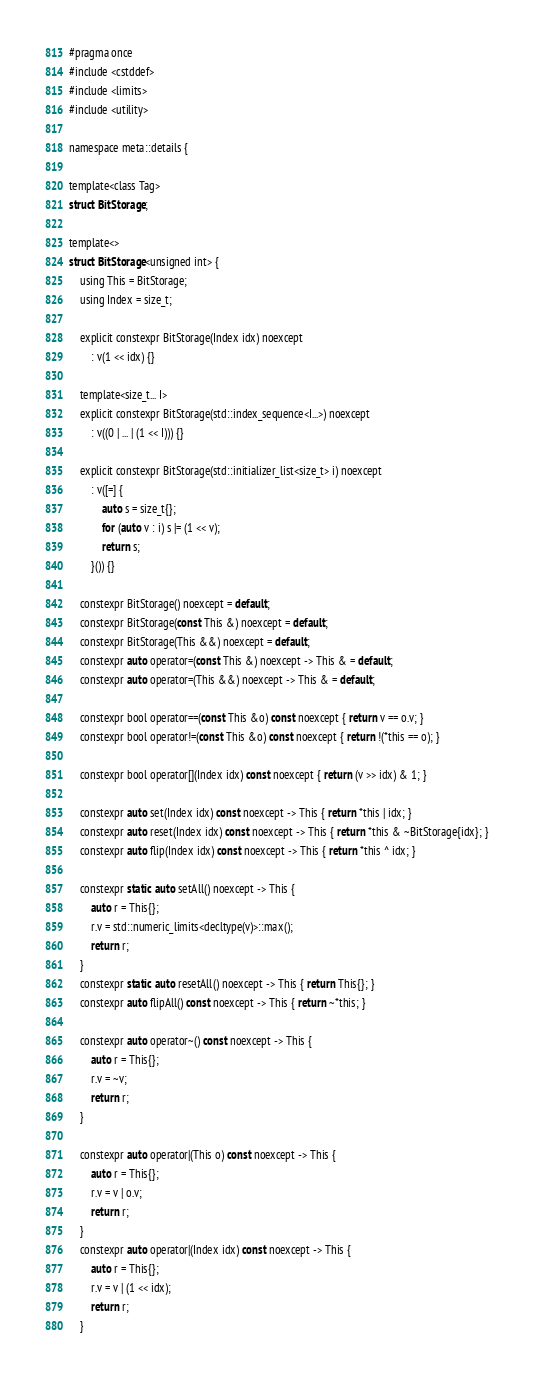Convert code to text. <code><loc_0><loc_0><loc_500><loc_500><_C_>#pragma once
#include <cstddef>
#include <limits>
#include <utility>

namespace meta::details {

template<class Tag>
struct BitStorage;

template<>
struct BitStorage<unsigned int> {
    using This = BitStorage;
    using Index = size_t;

    explicit constexpr BitStorage(Index idx) noexcept
        : v(1 << idx) {}

    template<size_t... I>
    explicit constexpr BitStorage(std::index_sequence<I...>) noexcept
        : v((0 | ... | (1 << I))) {}

    explicit constexpr BitStorage(std::initializer_list<size_t> i) noexcept
        : v([=] {
            auto s = size_t{};
            for (auto v : i) s |= (1 << v);
            return s;
        }()) {}

    constexpr BitStorage() noexcept = default;
    constexpr BitStorage(const This &) noexcept = default;
    constexpr BitStorage(This &&) noexcept = default;
    constexpr auto operator=(const This &) noexcept -> This & = default;
    constexpr auto operator=(This &&) noexcept -> This & = default;

    constexpr bool operator==(const This &o) const noexcept { return v == o.v; }
    constexpr bool operator!=(const This &o) const noexcept { return !(*this == o); }

    constexpr bool operator[](Index idx) const noexcept { return (v >> idx) & 1; }

    constexpr auto set(Index idx) const noexcept -> This { return *this | idx; }
    constexpr auto reset(Index idx) const noexcept -> This { return *this & ~BitStorage{idx}; }
    constexpr auto flip(Index idx) const noexcept -> This { return *this ^ idx; }

    constexpr static auto setAll() noexcept -> This {
        auto r = This{};
        r.v = std::numeric_limits<decltype(v)>::max();
        return r;
    }
    constexpr static auto resetAll() noexcept -> This { return This{}; }
    constexpr auto flipAll() const noexcept -> This { return ~*this; }

    constexpr auto operator~() const noexcept -> This {
        auto r = This{};
        r.v = ~v;
        return r;
    }

    constexpr auto operator|(This o) const noexcept -> This {
        auto r = This{};
        r.v = v | o.v;
        return r;
    }
    constexpr auto operator|(Index idx) const noexcept -> This {
        auto r = This{};
        r.v = v | (1 << idx);
        return r;
    }
</code> 